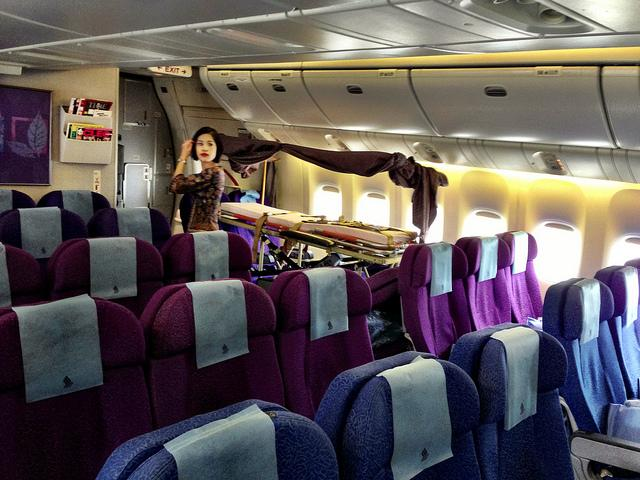Which country does this airline likely belong to? Please explain your reasoning. thailand. Looks to be from thailand. 